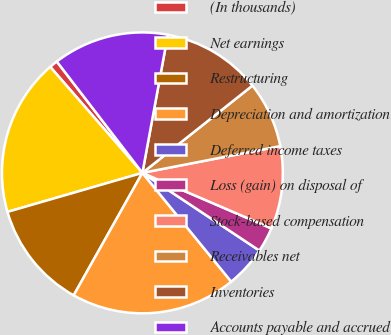Convert chart to OTSL. <chart><loc_0><loc_0><loc_500><loc_500><pie_chart><fcel>(In thousands)<fcel>Net earnings<fcel>Restructuring<fcel>Depreciation and amortization<fcel>Deferred income taxes<fcel>Loss (gain) on disposal of<fcel>Stock-based compensation<fcel>Receivables net<fcel>Inventories<fcel>Accounts payable and accrued<nl><fcel>0.96%<fcel>18.09%<fcel>12.38%<fcel>19.04%<fcel>4.77%<fcel>2.86%<fcel>9.52%<fcel>7.62%<fcel>11.43%<fcel>13.33%<nl></chart> 